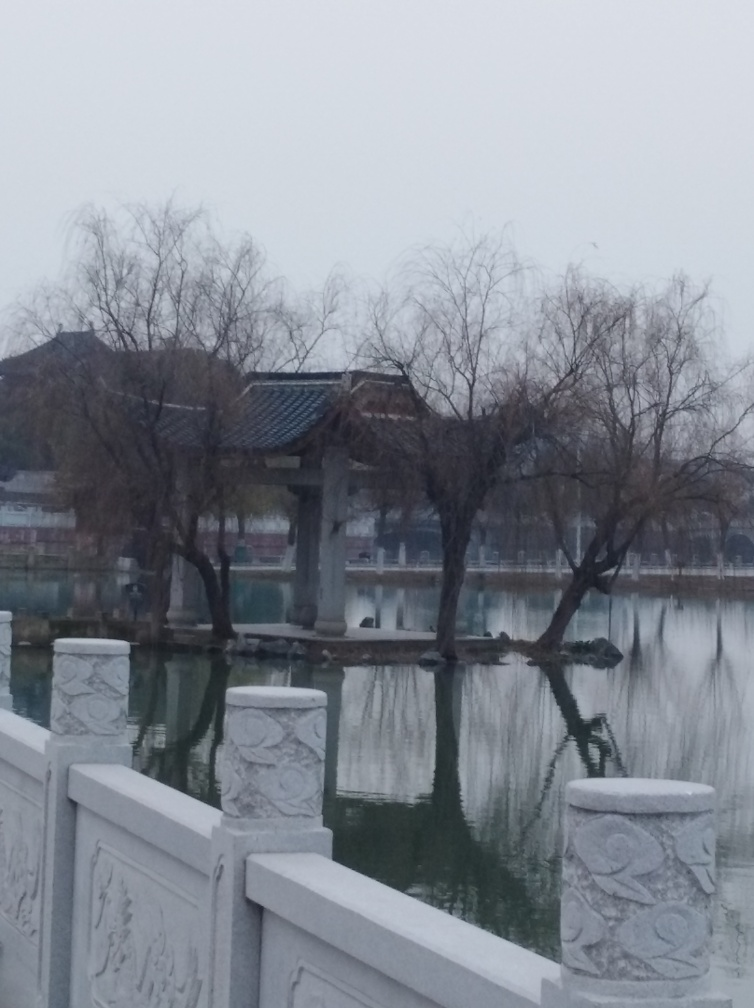Can you describe the architectural style of the building in the background? The architecture of the building in the image features characteristics that are common in traditional East Asian designs. It has a sweeping, multi-tiered roof with upturned eaves, indicating an influence that could be attributed to historical structures from regions like China, Korea, or Japan. The pagoda-like element atop suggests a possible use for contemplation or as a pavilion in a garden setting. 